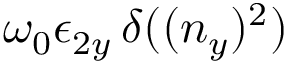<formula> <loc_0><loc_0><loc_500><loc_500>\omega _ { 0 } \epsilon _ { 2 y } \, \delta ( ( n _ { y } ) ^ { 2 } )</formula> 